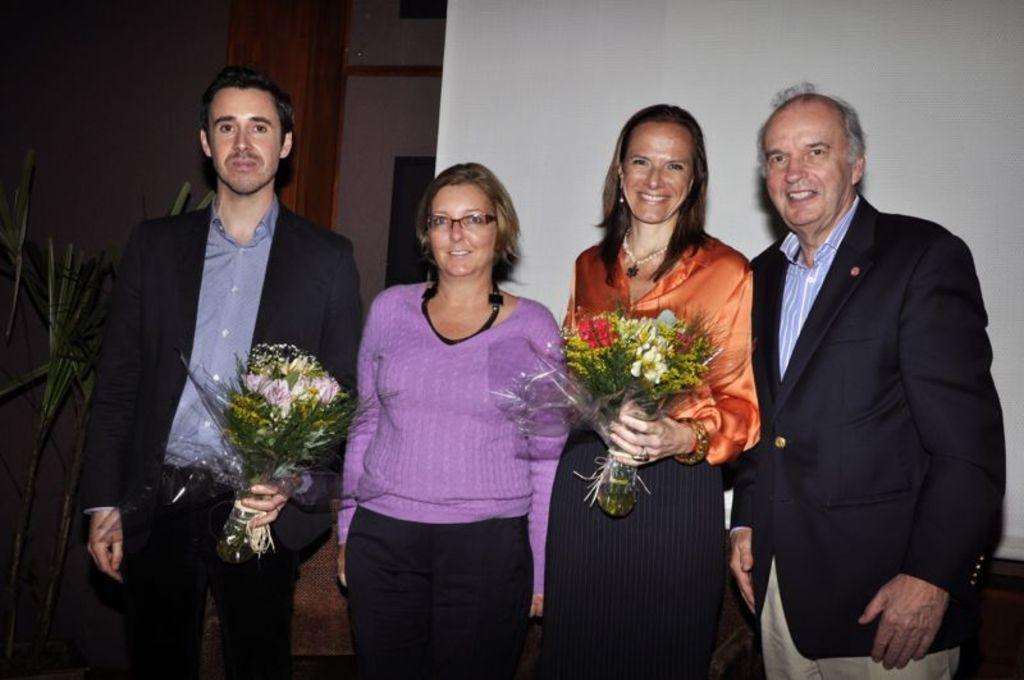Can you describe this image briefly? In this image, we can see persons wearing clothes and standing in front of the wall. There are two persons holding bouquets with their hands. There is a plant on the left side of the image. 